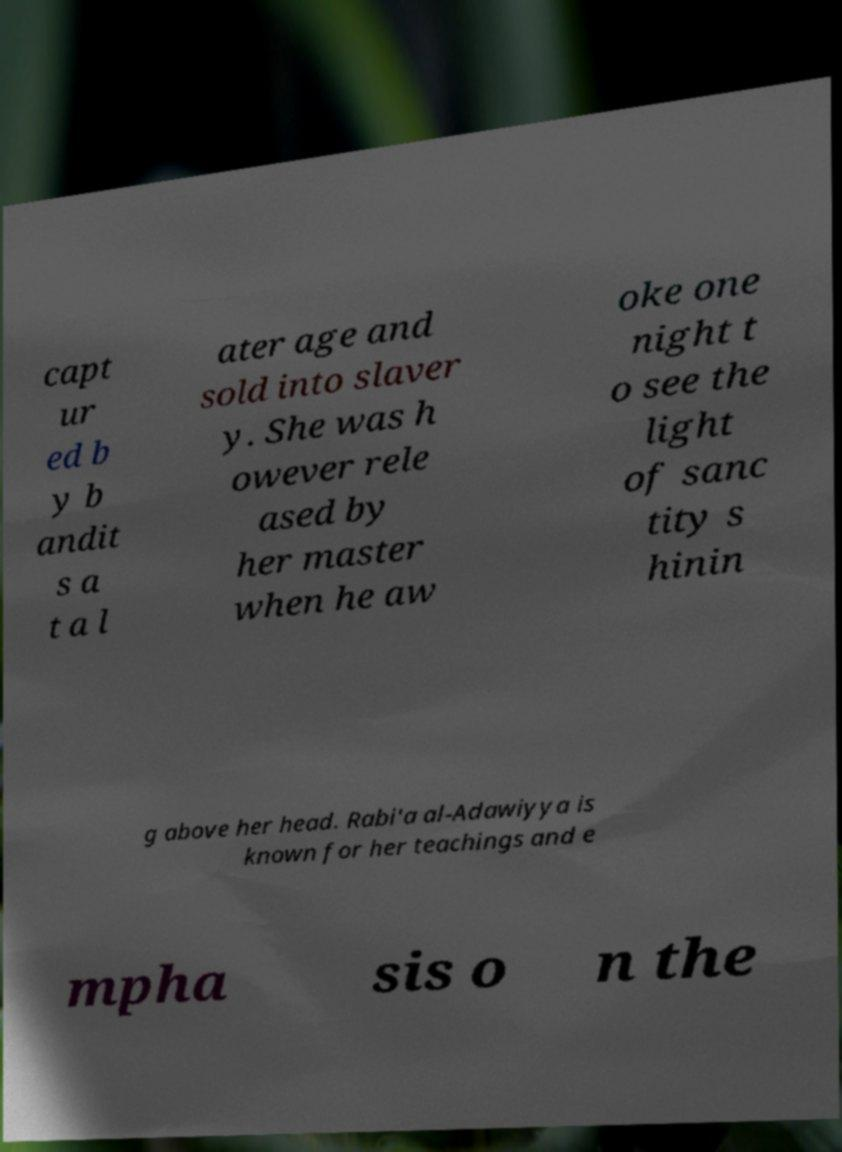Can you accurately transcribe the text from the provided image for me? capt ur ed b y b andit s a t a l ater age and sold into slaver y. She was h owever rele ased by her master when he aw oke one night t o see the light of sanc tity s hinin g above her head. Rabi'a al-Adawiyya is known for her teachings and e mpha sis o n the 